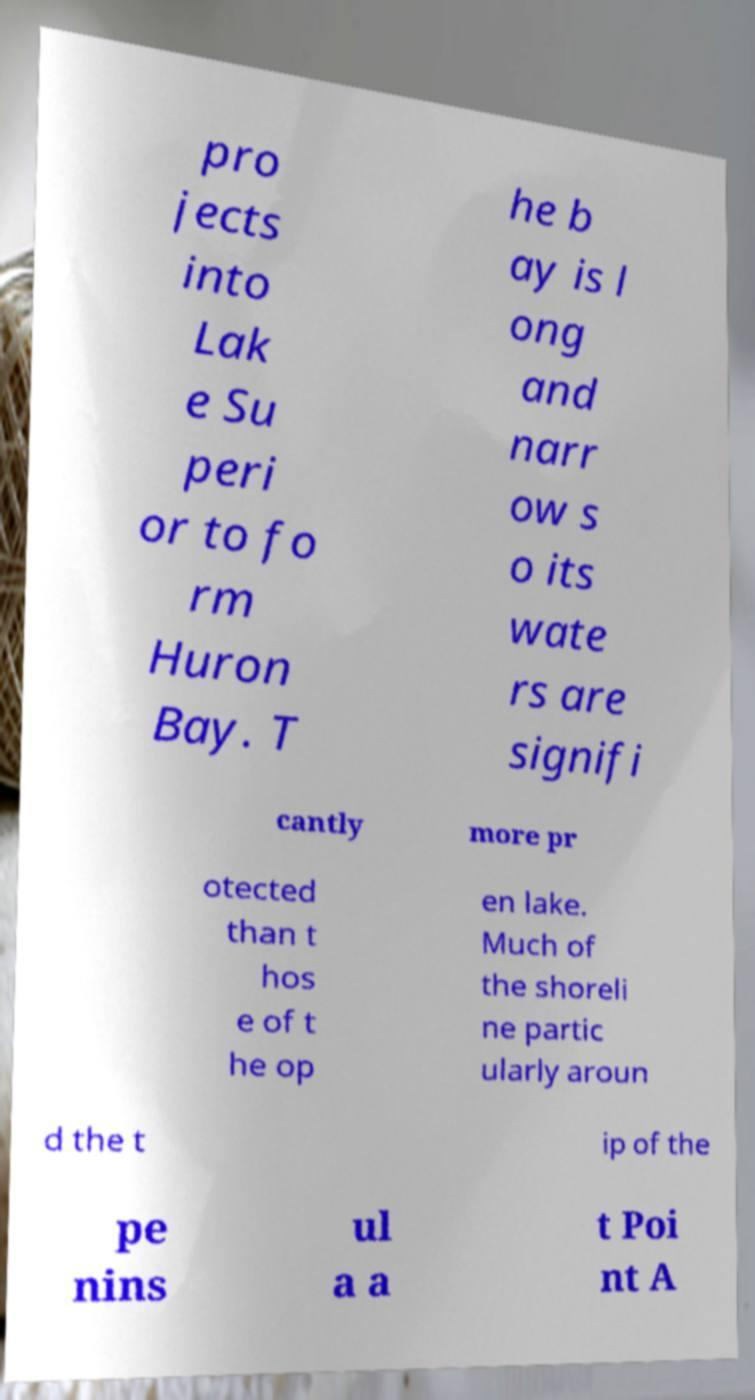Could you assist in decoding the text presented in this image and type it out clearly? pro jects into Lak e Su peri or to fo rm Huron Bay. T he b ay is l ong and narr ow s o its wate rs are signifi cantly more pr otected than t hos e of t he op en lake. Much of the shoreli ne partic ularly aroun d the t ip of the pe nins ul a a t Poi nt A 